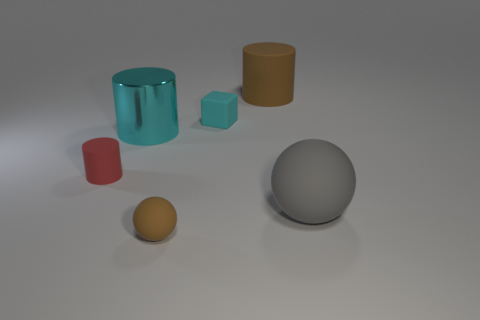Subtract all tiny red rubber cylinders. How many cylinders are left? 2 Add 3 small purple cubes. How many objects exist? 9 Subtract all cubes. How many objects are left? 5 Add 5 red objects. How many red objects exist? 6 Subtract 1 brown spheres. How many objects are left? 5 Subtract all yellow shiny cubes. Subtract all large brown cylinders. How many objects are left? 5 Add 6 tiny brown matte spheres. How many tiny brown matte spheres are left? 7 